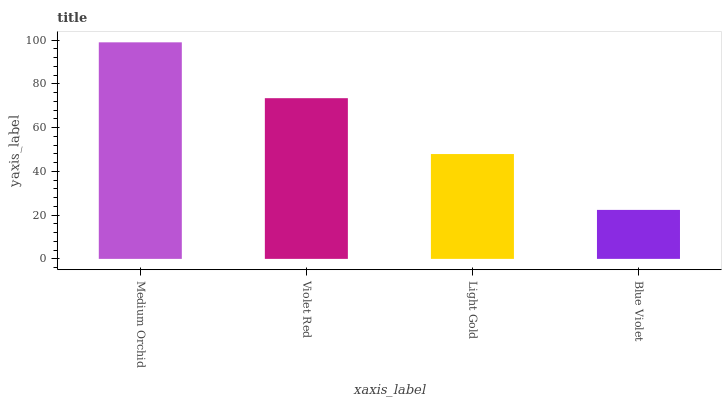Is Blue Violet the minimum?
Answer yes or no. Yes. Is Medium Orchid the maximum?
Answer yes or no. Yes. Is Violet Red the minimum?
Answer yes or no. No. Is Violet Red the maximum?
Answer yes or no. No. Is Medium Orchid greater than Violet Red?
Answer yes or no. Yes. Is Violet Red less than Medium Orchid?
Answer yes or no. Yes. Is Violet Red greater than Medium Orchid?
Answer yes or no. No. Is Medium Orchid less than Violet Red?
Answer yes or no. No. Is Violet Red the high median?
Answer yes or no. Yes. Is Light Gold the low median?
Answer yes or no. Yes. Is Medium Orchid the high median?
Answer yes or no. No. Is Violet Red the low median?
Answer yes or no. No. 